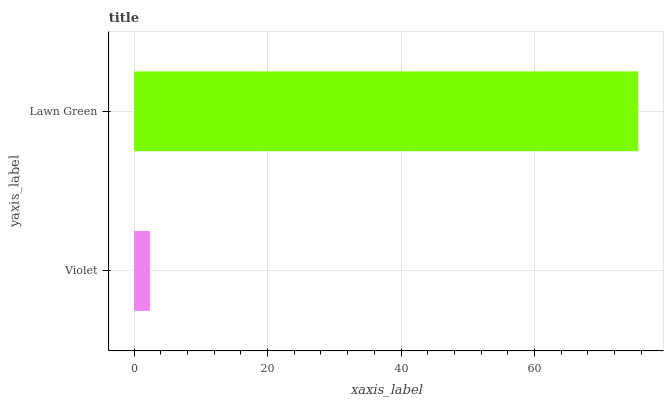Is Violet the minimum?
Answer yes or no. Yes. Is Lawn Green the maximum?
Answer yes or no. Yes. Is Lawn Green the minimum?
Answer yes or no. No. Is Lawn Green greater than Violet?
Answer yes or no. Yes. Is Violet less than Lawn Green?
Answer yes or no. Yes. Is Violet greater than Lawn Green?
Answer yes or no. No. Is Lawn Green less than Violet?
Answer yes or no. No. Is Lawn Green the high median?
Answer yes or no. Yes. Is Violet the low median?
Answer yes or no. Yes. Is Violet the high median?
Answer yes or no. No. Is Lawn Green the low median?
Answer yes or no. No. 